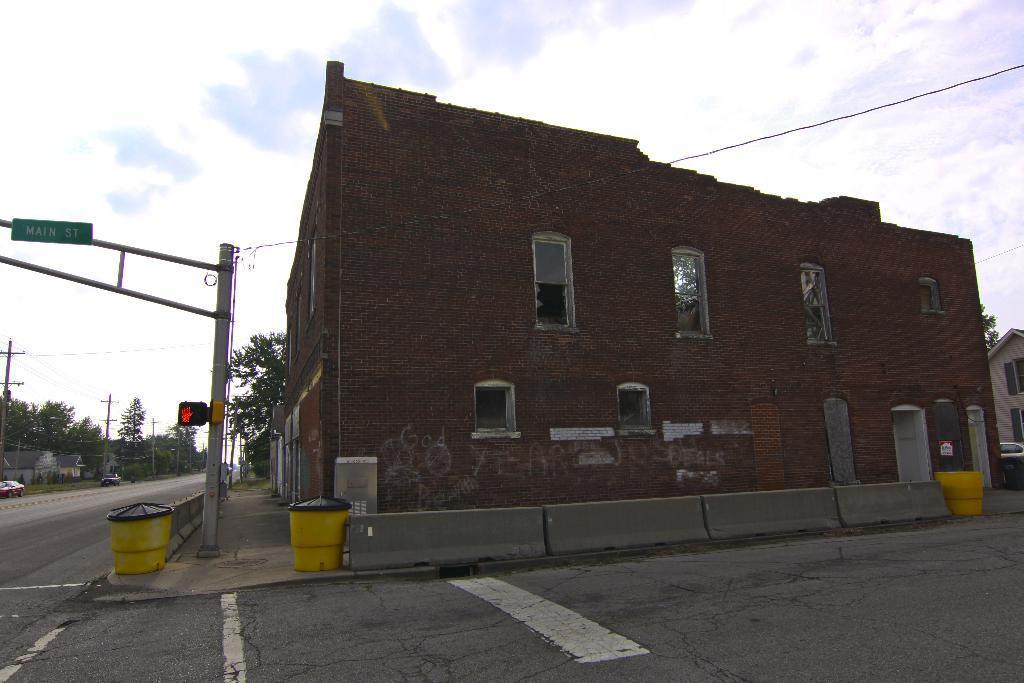Please provide a concise description of this image. In this image there is the sky truncated towards the top of the image, there are trees truncated towards the left of the image, there are poles, there are wires, there is a wire towards the right of the image, there is road truncated towards the bottom of the image, there are objects on the ground, there is a building towards the right of the image, there are windows, there is a door, there are cars, there is a board, there is text on the board. 